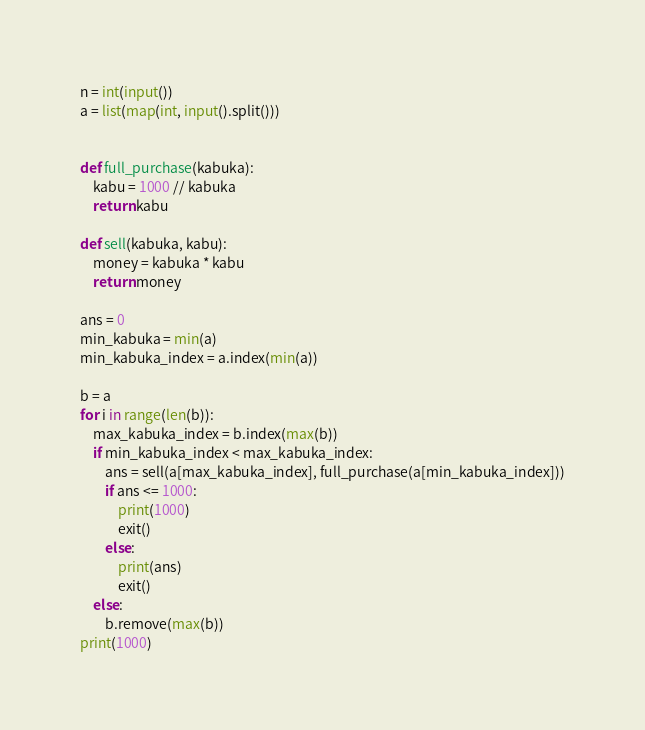<code> <loc_0><loc_0><loc_500><loc_500><_Python_>n = int(input())
a = list(map(int, input().split()))


def full_purchase(kabuka):
    kabu = 1000 // kabuka
    return kabu

def sell(kabuka, kabu):
    money = kabuka * kabu
    return money

ans = 0
min_kabuka = min(a)
min_kabuka_index = a.index(min(a))

b = a
for i in range(len(b)):
    max_kabuka_index = b.index(max(b))
    if min_kabuka_index < max_kabuka_index:
        ans = sell(a[max_kabuka_index], full_purchase(a[min_kabuka_index]))
        if ans <= 1000:
            print(1000)
            exit()
        else:
            print(ans)
            exit()
    else:
        b.remove(max(b))
print(1000)
</code> 